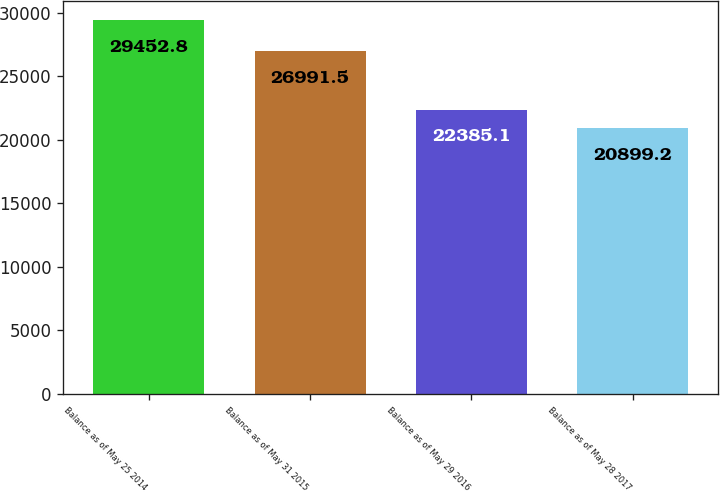Convert chart to OTSL. <chart><loc_0><loc_0><loc_500><loc_500><bar_chart><fcel>Balance as of May 25 2014<fcel>Balance as of May 31 2015<fcel>Balance as of May 29 2016<fcel>Balance as of May 28 2017<nl><fcel>29452.8<fcel>26991.5<fcel>22385.1<fcel>20899.2<nl></chart> 